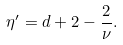Convert formula to latex. <formula><loc_0><loc_0><loc_500><loc_500>\eta ^ { \prime } = d + 2 - \frac { 2 } { \nu } .</formula> 